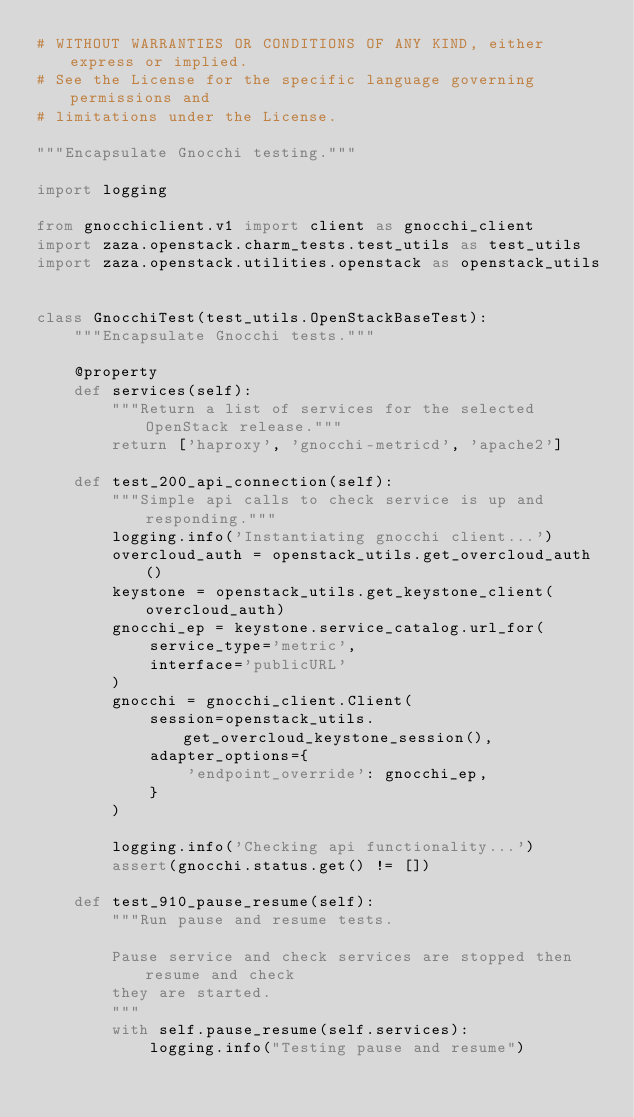<code> <loc_0><loc_0><loc_500><loc_500><_Python_># WITHOUT WARRANTIES OR CONDITIONS OF ANY KIND, either express or implied.
# See the License for the specific language governing permissions and
# limitations under the License.

"""Encapsulate Gnocchi testing."""

import logging

from gnocchiclient.v1 import client as gnocchi_client
import zaza.openstack.charm_tests.test_utils as test_utils
import zaza.openstack.utilities.openstack as openstack_utils


class GnocchiTest(test_utils.OpenStackBaseTest):
    """Encapsulate Gnocchi tests."""

    @property
    def services(self):
        """Return a list of services for the selected OpenStack release."""
        return ['haproxy', 'gnocchi-metricd', 'apache2']

    def test_200_api_connection(self):
        """Simple api calls to check service is up and responding."""
        logging.info('Instantiating gnocchi client...')
        overcloud_auth = openstack_utils.get_overcloud_auth()
        keystone = openstack_utils.get_keystone_client(overcloud_auth)
        gnocchi_ep = keystone.service_catalog.url_for(
            service_type='metric',
            interface='publicURL'
        )
        gnocchi = gnocchi_client.Client(
            session=openstack_utils.get_overcloud_keystone_session(),
            adapter_options={
                'endpoint_override': gnocchi_ep,
            }
        )

        logging.info('Checking api functionality...')
        assert(gnocchi.status.get() != [])

    def test_910_pause_resume(self):
        """Run pause and resume tests.

        Pause service and check services are stopped then resume and check
        they are started.
        """
        with self.pause_resume(self.services):
            logging.info("Testing pause and resume")
</code> 